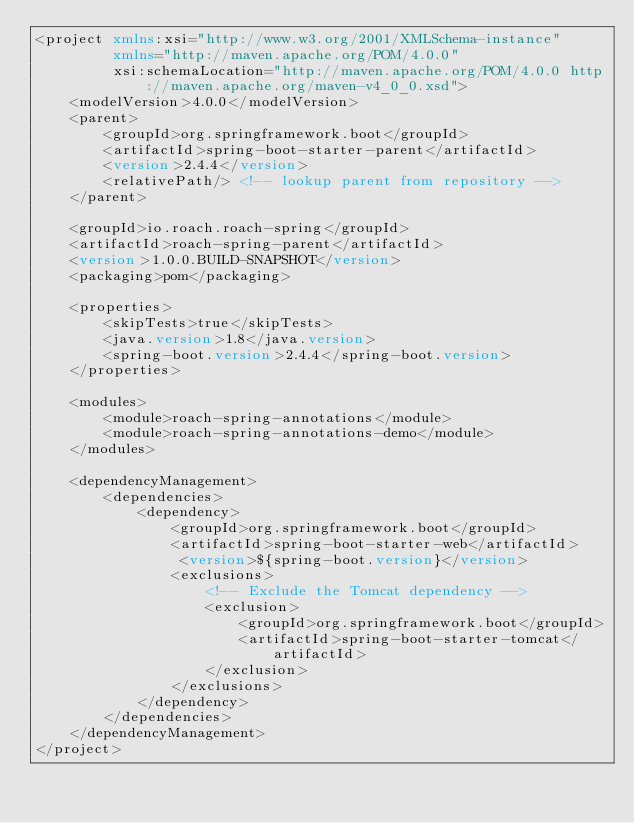<code> <loc_0><loc_0><loc_500><loc_500><_XML_><project xmlns:xsi="http://www.w3.org/2001/XMLSchema-instance"
         xmlns="http://maven.apache.org/POM/4.0.0"
         xsi:schemaLocation="http://maven.apache.org/POM/4.0.0 http://maven.apache.org/maven-v4_0_0.xsd">
    <modelVersion>4.0.0</modelVersion>
    <parent>
        <groupId>org.springframework.boot</groupId>
        <artifactId>spring-boot-starter-parent</artifactId>
        <version>2.4.4</version>
        <relativePath/> <!-- lookup parent from repository -->
    </parent>

    <groupId>io.roach.roach-spring</groupId>
    <artifactId>roach-spring-parent</artifactId>
    <version>1.0.0.BUILD-SNAPSHOT</version>
    <packaging>pom</packaging>

    <properties>
        <skipTests>true</skipTests>
        <java.version>1.8</java.version>
        <spring-boot.version>2.4.4</spring-boot.version>
    </properties>

    <modules>
        <module>roach-spring-annotations</module>
        <module>roach-spring-annotations-demo</module>
    </modules>

    <dependencyManagement>
        <dependencies>
            <dependency>
                <groupId>org.springframework.boot</groupId>
                <artifactId>spring-boot-starter-web</artifactId>
                 <version>${spring-boot.version}</version>
                <exclusions>
                    <!-- Exclude the Tomcat dependency -->
                    <exclusion>
                        <groupId>org.springframework.boot</groupId>
                        <artifactId>spring-boot-starter-tomcat</artifactId>
                    </exclusion>
                </exclusions>
            </dependency>
        </dependencies>
    </dependencyManagement>
</project>
</code> 